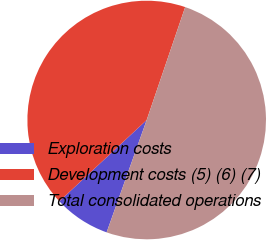<chart> <loc_0><loc_0><loc_500><loc_500><pie_chart><fcel>Exploration costs<fcel>Development costs (5) (6) (7)<fcel>Total consolidated operations<nl><fcel>7.62%<fcel>42.15%<fcel>50.22%<nl></chart> 